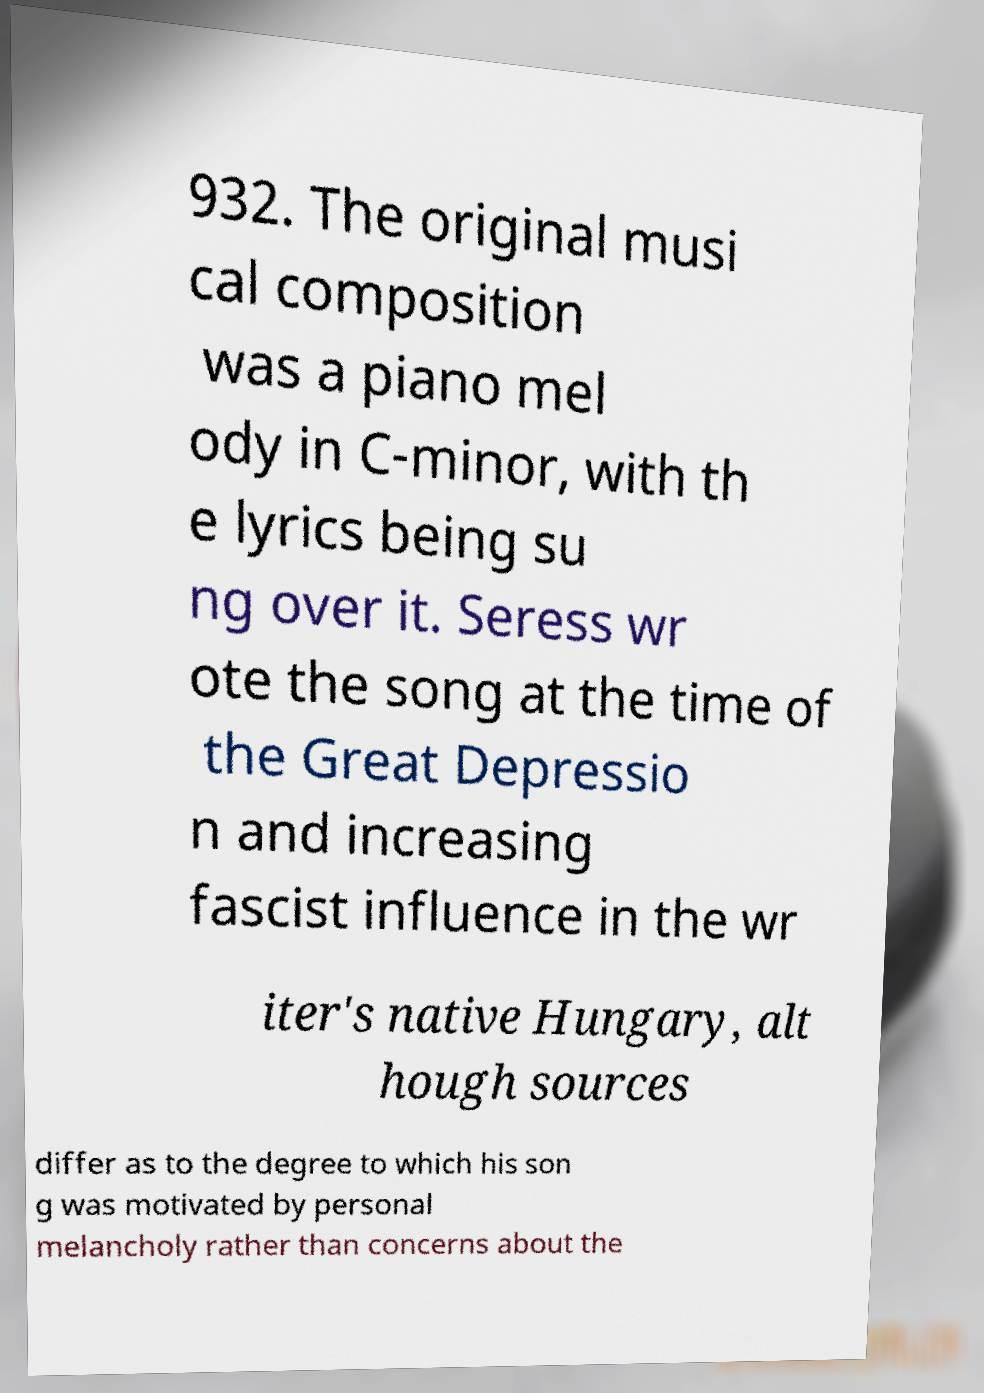Please identify and transcribe the text found in this image. 932. The original musi cal composition was a piano mel ody in C-minor, with th e lyrics being su ng over it. Seress wr ote the song at the time of the Great Depressio n and increasing fascist influence in the wr iter's native Hungary, alt hough sources differ as to the degree to which his son g was motivated by personal melancholy rather than concerns about the 